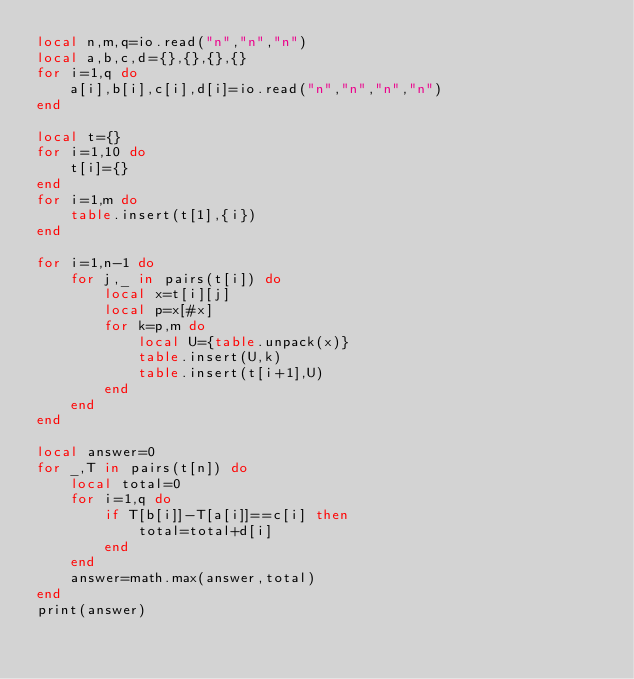Convert code to text. <code><loc_0><loc_0><loc_500><loc_500><_Lua_>local n,m,q=io.read("n","n","n")
local a,b,c,d={},{},{},{}
for i=1,q do
    a[i],b[i],c[i],d[i]=io.read("n","n","n","n")
end

local t={}
for i=1,10 do
    t[i]={}
end
for i=1,m do
    table.insert(t[1],{i})
end

for i=1,n-1 do
    for j,_ in pairs(t[i]) do
        local x=t[i][j]
        local p=x[#x]
        for k=p,m do
            local U={table.unpack(x)}
            table.insert(U,k)
            table.insert(t[i+1],U)
        end
    end
end

local answer=0
for _,T in pairs(t[n]) do
    local total=0
    for i=1,q do
        if T[b[i]]-T[a[i]]==c[i] then
            total=total+d[i]
        end
    end
    answer=math.max(answer,total)
end
print(answer)</code> 